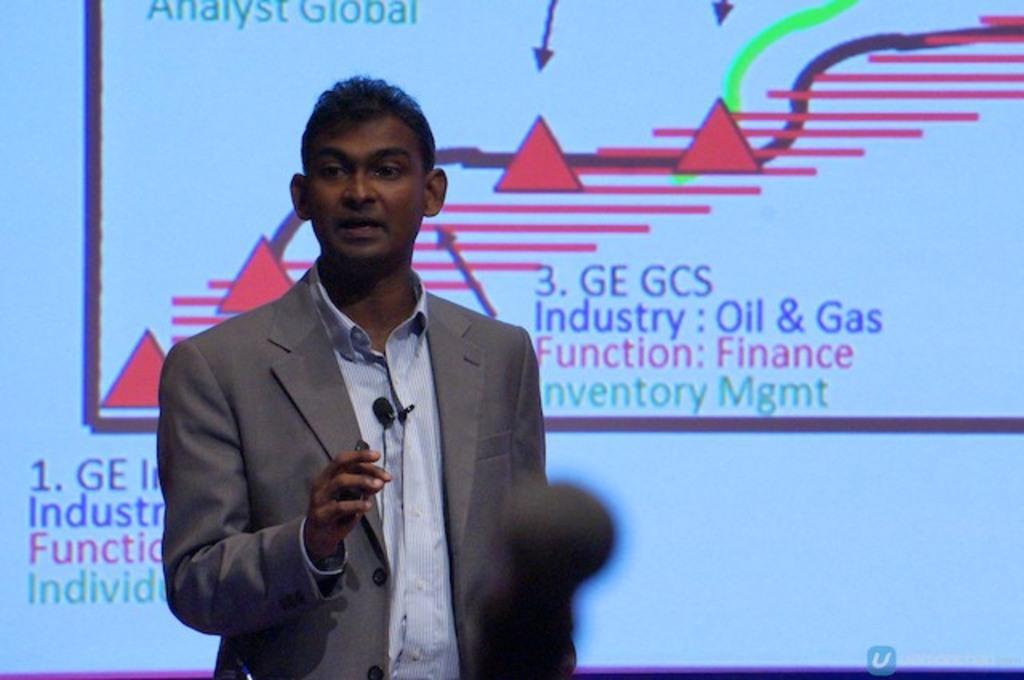Can you describe this image briefly? In the center of this picture we can see a person wearing blazer, holding some object and standing. In the background we can see the text and some pictures on an object which seems to be the projector screen and we can see some other objects. 